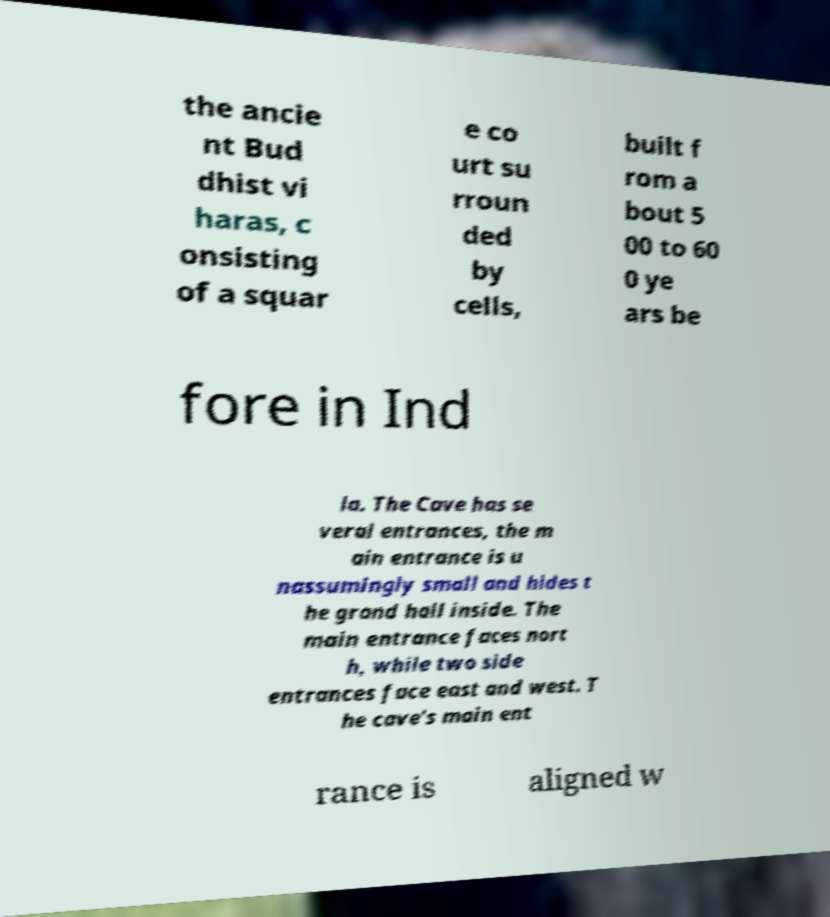Can you read and provide the text displayed in the image?This photo seems to have some interesting text. Can you extract and type it out for me? the ancie nt Bud dhist vi haras, c onsisting of a squar e co urt su rroun ded by cells, built f rom a bout 5 00 to 60 0 ye ars be fore in Ind ia. The Cave has se veral entrances, the m ain entrance is u nassumingly small and hides t he grand hall inside. The main entrance faces nort h, while two side entrances face east and west. T he cave's main ent rance is aligned w 